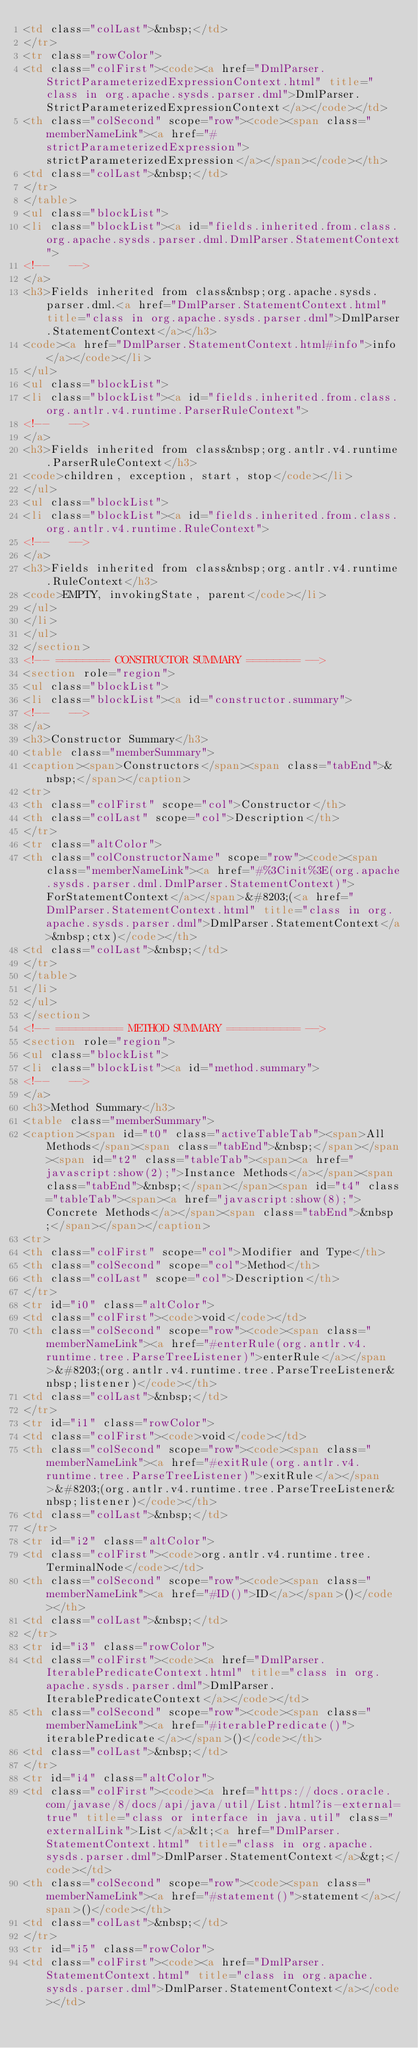<code> <loc_0><loc_0><loc_500><loc_500><_HTML_><td class="colLast">&nbsp;</td>
</tr>
<tr class="rowColor">
<td class="colFirst"><code><a href="DmlParser.StrictParameterizedExpressionContext.html" title="class in org.apache.sysds.parser.dml">DmlParser.StrictParameterizedExpressionContext</a></code></td>
<th class="colSecond" scope="row"><code><span class="memberNameLink"><a href="#strictParameterizedExpression">strictParameterizedExpression</a></span></code></th>
<td class="colLast">&nbsp;</td>
</tr>
</table>
<ul class="blockList">
<li class="blockList"><a id="fields.inherited.from.class.org.apache.sysds.parser.dml.DmlParser.StatementContext">
<!--   -->
</a>
<h3>Fields inherited from class&nbsp;org.apache.sysds.parser.dml.<a href="DmlParser.StatementContext.html" title="class in org.apache.sysds.parser.dml">DmlParser.StatementContext</a></h3>
<code><a href="DmlParser.StatementContext.html#info">info</a></code></li>
</ul>
<ul class="blockList">
<li class="blockList"><a id="fields.inherited.from.class.org.antlr.v4.runtime.ParserRuleContext">
<!--   -->
</a>
<h3>Fields inherited from class&nbsp;org.antlr.v4.runtime.ParserRuleContext</h3>
<code>children, exception, start, stop</code></li>
</ul>
<ul class="blockList">
<li class="blockList"><a id="fields.inherited.from.class.org.antlr.v4.runtime.RuleContext">
<!--   -->
</a>
<h3>Fields inherited from class&nbsp;org.antlr.v4.runtime.RuleContext</h3>
<code>EMPTY, invokingState, parent</code></li>
</ul>
</li>
</ul>
</section>
<!-- ======== CONSTRUCTOR SUMMARY ======== -->
<section role="region">
<ul class="blockList">
<li class="blockList"><a id="constructor.summary">
<!--   -->
</a>
<h3>Constructor Summary</h3>
<table class="memberSummary">
<caption><span>Constructors</span><span class="tabEnd">&nbsp;</span></caption>
<tr>
<th class="colFirst" scope="col">Constructor</th>
<th class="colLast" scope="col">Description</th>
</tr>
<tr class="altColor">
<th class="colConstructorName" scope="row"><code><span class="memberNameLink"><a href="#%3Cinit%3E(org.apache.sysds.parser.dml.DmlParser.StatementContext)">ForStatementContext</a></span>&#8203;(<a href="DmlParser.StatementContext.html" title="class in org.apache.sysds.parser.dml">DmlParser.StatementContext</a>&nbsp;ctx)</code></th>
<td class="colLast">&nbsp;</td>
</tr>
</table>
</li>
</ul>
</section>
<!-- ========== METHOD SUMMARY =========== -->
<section role="region">
<ul class="blockList">
<li class="blockList"><a id="method.summary">
<!--   -->
</a>
<h3>Method Summary</h3>
<table class="memberSummary">
<caption><span id="t0" class="activeTableTab"><span>All Methods</span><span class="tabEnd">&nbsp;</span></span><span id="t2" class="tableTab"><span><a href="javascript:show(2);">Instance Methods</a></span><span class="tabEnd">&nbsp;</span></span><span id="t4" class="tableTab"><span><a href="javascript:show(8);">Concrete Methods</a></span><span class="tabEnd">&nbsp;</span></span></caption>
<tr>
<th class="colFirst" scope="col">Modifier and Type</th>
<th class="colSecond" scope="col">Method</th>
<th class="colLast" scope="col">Description</th>
</tr>
<tr id="i0" class="altColor">
<td class="colFirst"><code>void</code></td>
<th class="colSecond" scope="row"><code><span class="memberNameLink"><a href="#enterRule(org.antlr.v4.runtime.tree.ParseTreeListener)">enterRule</a></span>&#8203;(org.antlr.v4.runtime.tree.ParseTreeListener&nbsp;listener)</code></th>
<td class="colLast">&nbsp;</td>
</tr>
<tr id="i1" class="rowColor">
<td class="colFirst"><code>void</code></td>
<th class="colSecond" scope="row"><code><span class="memberNameLink"><a href="#exitRule(org.antlr.v4.runtime.tree.ParseTreeListener)">exitRule</a></span>&#8203;(org.antlr.v4.runtime.tree.ParseTreeListener&nbsp;listener)</code></th>
<td class="colLast">&nbsp;</td>
</tr>
<tr id="i2" class="altColor">
<td class="colFirst"><code>org.antlr.v4.runtime.tree.TerminalNode</code></td>
<th class="colSecond" scope="row"><code><span class="memberNameLink"><a href="#ID()">ID</a></span>()</code></th>
<td class="colLast">&nbsp;</td>
</tr>
<tr id="i3" class="rowColor">
<td class="colFirst"><code><a href="DmlParser.IterablePredicateContext.html" title="class in org.apache.sysds.parser.dml">DmlParser.IterablePredicateContext</a></code></td>
<th class="colSecond" scope="row"><code><span class="memberNameLink"><a href="#iterablePredicate()">iterablePredicate</a></span>()</code></th>
<td class="colLast">&nbsp;</td>
</tr>
<tr id="i4" class="altColor">
<td class="colFirst"><code><a href="https://docs.oracle.com/javase/8/docs/api/java/util/List.html?is-external=true" title="class or interface in java.util" class="externalLink">List</a>&lt;<a href="DmlParser.StatementContext.html" title="class in org.apache.sysds.parser.dml">DmlParser.StatementContext</a>&gt;</code></td>
<th class="colSecond" scope="row"><code><span class="memberNameLink"><a href="#statement()">statement</a></span>()</code></th>
<td class="colLast">&nbsp;</td>
</tr>
<tr id="i5" class="rowColor">
<td class="colFirst"><code><a href="DmlParser.StatementContext.html" title="class in org.apache.sysds.parser.dml">DmlParser.StatementContext</a></code></td></code> 